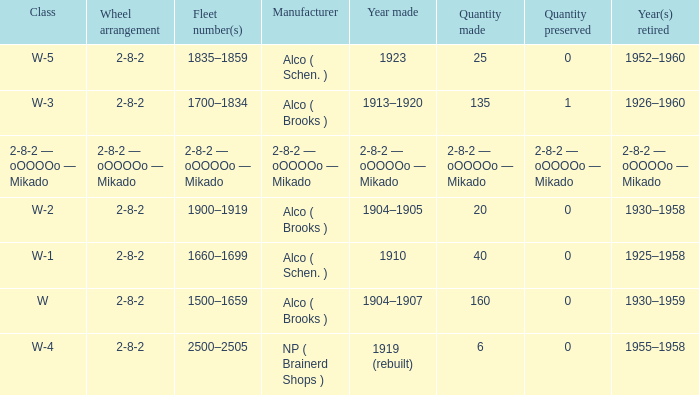What type of locomotive has a 2-8-2 wheel arrangement and 25 examples manufactured? W-5. 